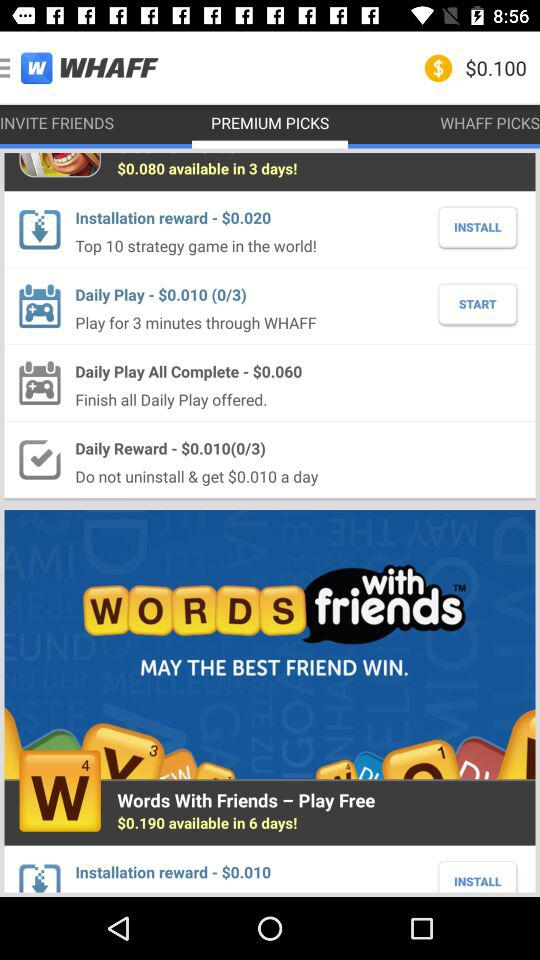Which tab is open? The open tab is "PREMIUM PICKS". 